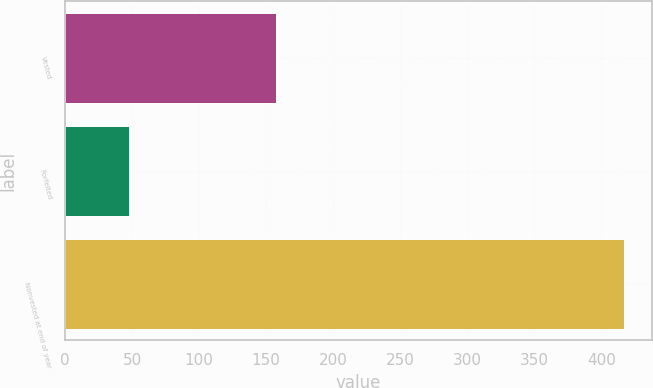Convert chart to OTSL. <chart><loc_0><loc_0><loc_500><loc_500><bar_chart><fcel>Vested<fcel>Forfeited<fcel>Nonvested at end of year<nl><fcel>157<fcel>48<fcel>417<nl></chart> 